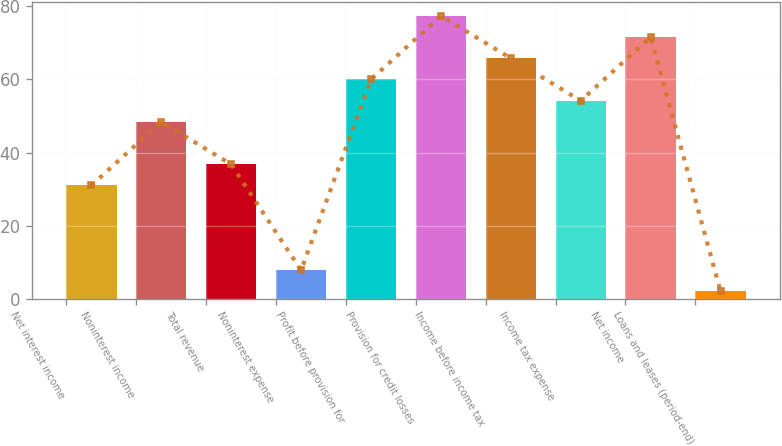Convert chart. <chart><loc_0><loc_0><loc_500><loc_500><bar_chart><fcel>Net interest income<fcel>Noninterest income<fcel>Total revenue<fcel>Noninterest expense<fcel>Profit before provision for<fcel>Provision for credit losses<fcel>Income before income tax<fcel>Income tax expense<fcel>Net income<fcel>Loans and leases (period-end)<nl><fcel>31<fcel>48.4<fcel>36.8<fcel>7.8<fcel>60<fcel>77.4<fcel>65.8<fcel>54.2<fcel>71.6<fcel>2<nl></chart> 